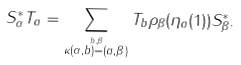<formula> <loc_0><loc_0><loc_500><loc_500>S _ { \alpha } ^ { * } T _ { a } = \sum _ { \stackrel { b , \beta } { \kappa ( \alpha , b ) = ( a , \beta ) } } T _ { b } \rho _ { \beta } ( \eta _ { a } ( 1 ) ) S _ { \beta } ^ { * } .</formula> 